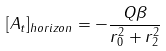<formula> <loc_0><loc_0><loc_500><loc_500>[ A _ { t } ] _ { h o r i z o n } = - \frac { Q \beta } { r _ { 0 } ^ { 2 } + r _ { 2 } ^ { 2 } }</formula> 